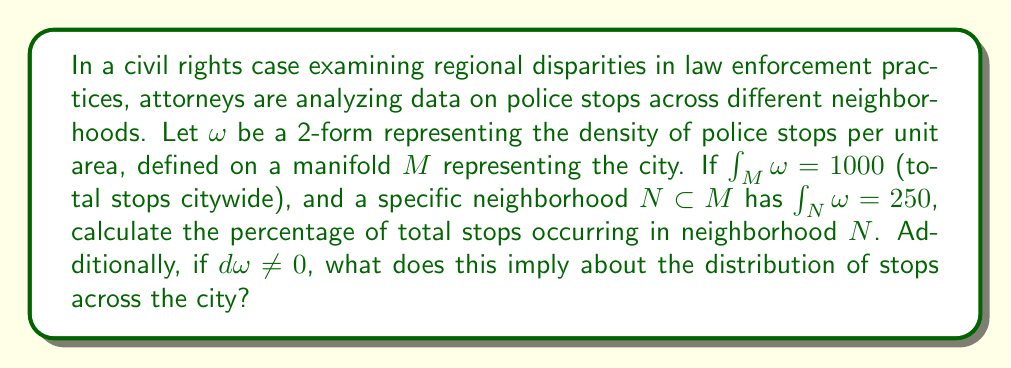Give your solution to this math problem. To solve this problem, we'll follow these steps:

1) The total number of stops citywide is given by the integral of $\omega$ over the entire manifold $M$:

   $\int_M \omega = 1000$

2) The number of stops in neighborhood $N$ is given by the integral of $\omega$ over $N$:

   $\int_N \omega = 250$

3) To calculate the percentage of stops occurring in $N$, we divide the stops in $N$ by the total stops and multiply by 100:

   Percentage = $\frac{\int_N \omega}{\int_M \omega} \times 100\% = \frac{250}{1000} \times 100\% = 25\%$

4) Regarding $d\omega \neq 0$:
   In differential geometry, if the exterior derivative of a form is non-zero ($d\omega \neq 0$), it implies that the form is not closed. In the context of our problem:
   
   - A closed form ($d\omega = 0$) would represent a uniform distribution of stops across the city.
   - $d\omega \neq 0$ implies that the distribution of stops is not uniform across the city.
   
   This non-uniformity could indicate potential disparities in law enforcement practices across different regions, which is crucial information for civil rights attorneys investigating constitutional issues related to equal protection under the law.
Answer: 25%; non-uniform distribution of stops 